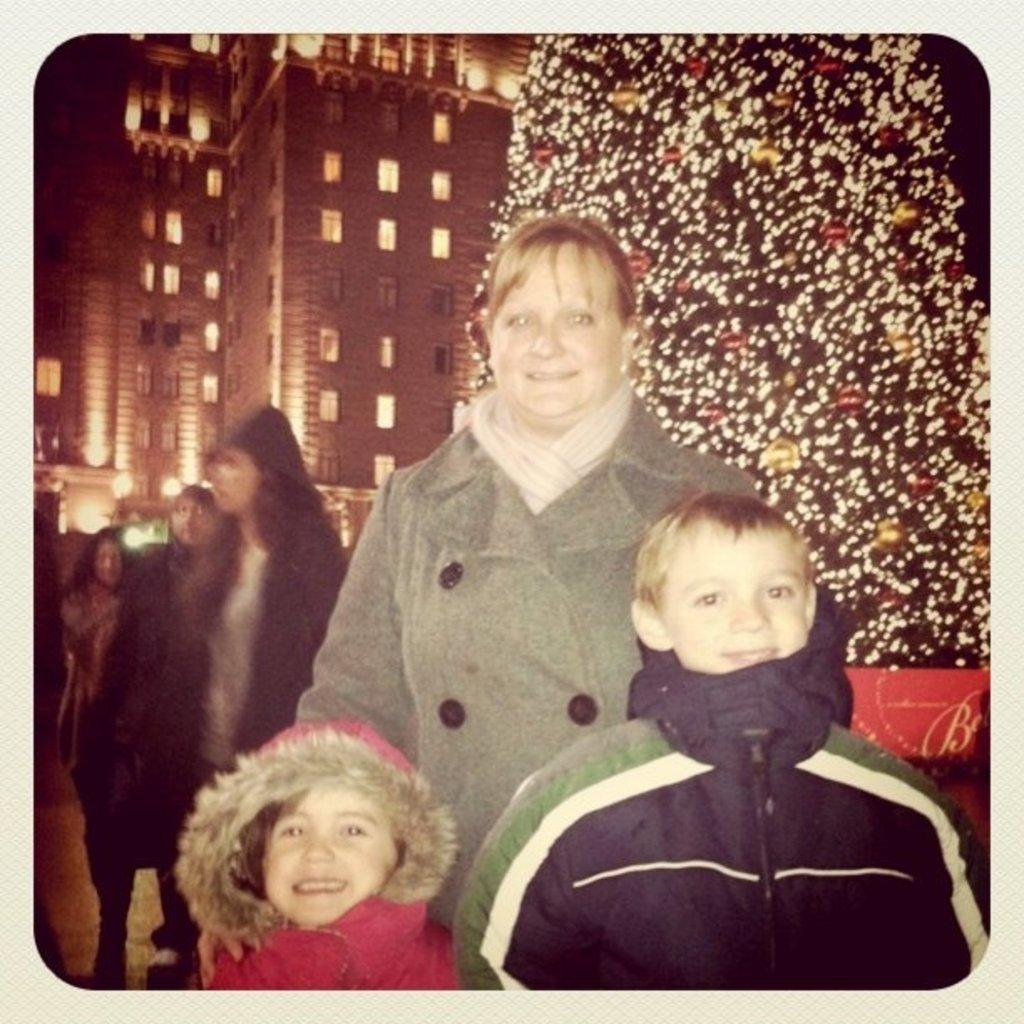What can be seen in the image? There is a group of people in the image, including kids and a woman. How are the people in the image feeling? The woman and kids are smiling in the image. What is present in the background of the image? There is a Christmas tree and buildings in the background of the image. What type of collar is the woman wearing in the image? There is no collar visible on the woman in the image. What advertisement can be seen on the Christmas tree in the image? There is no advertisement present on the Christmas tree in the image. 